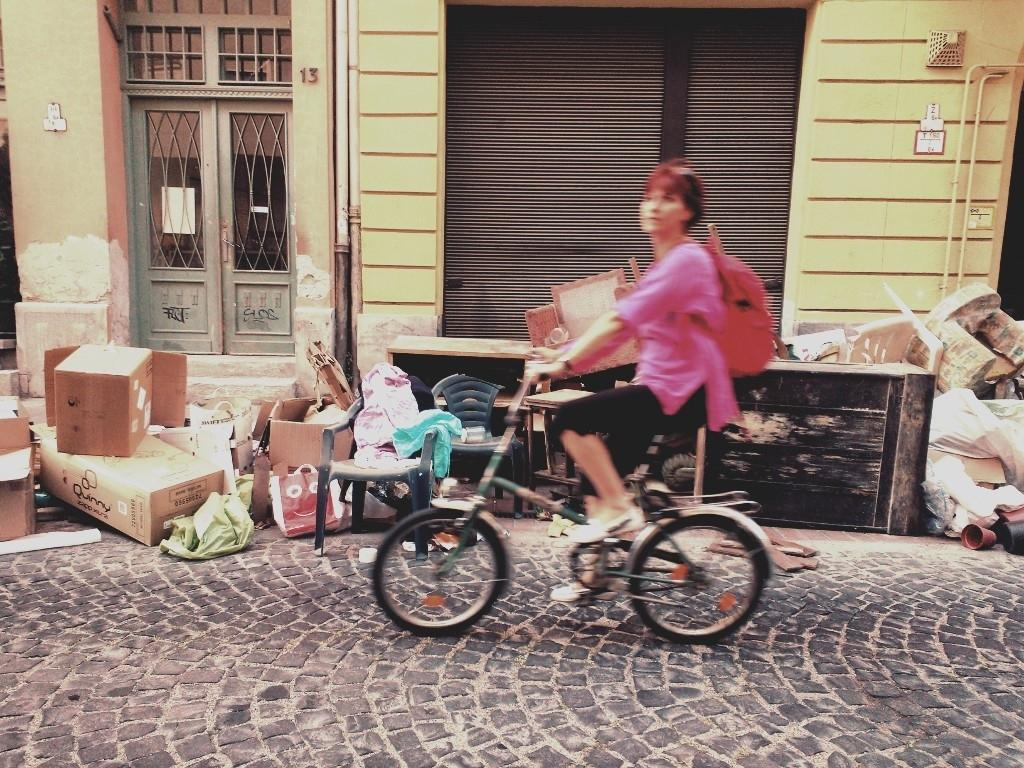Who is the main subject in the image? There is a woman in the image. What is the woman doing in the image? The woman is riding a bicycle. Where is the bicycle located? The bicycle is on the road. What can be seen in the background of the image? There is a building in the background of the image. What is present on the floor in the image? There are boxes and other objects on the floor. Can you tell me how many yams are on the bicycle in the image? There are no yams present in the image; the woman is riding a bicycle on the road. What type of bird can be seen flying in the background of the image? There are no birds visible in the image; the background features a building. 